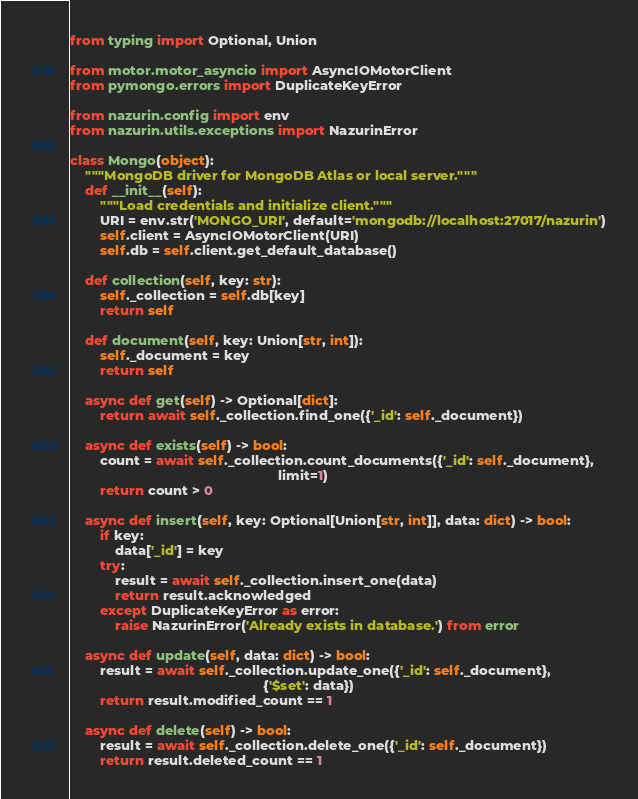Convert code to text. <code><loc_0><loc_0><loc_500><loc_500><_Python_>from typing import Optional, Union

from motor.motor_asyncio import AsyncIOMotorClient
from pymongo.errors import DuplicateKeyError

from nazurin.config import env
from nazurin.utils.exceptions import NazurinError

class Mongo(object):
    """MongoDB driver for MongoDB Atlas or local server."""
    def __init__(self):
        """Load credentials and initialize client."""
        URI = env.str('MONGO_URI', default='mongodb://localhost:27017/nazurin')
        self.client = AsyncIOMotorClient(URI)
        self.db = self.client.get_default_database()

    def collection(self, key: str):
        self._collection = self.db[key]
        return self

    def document(self, key: Union[str, int]):
        self._document = key
        return self

    async def get(self) -> Optional[dict]:
        return await self._collection.find_one({'_id': self._document})

    async def exists(self) -> bool:
        count = await self._collection.count_documents({'_id': self._document},
                                                       limit=1)
        return count > 0

    async def insert(self, key: Optional[Union[str, int]], data: dict) -> bool:
        if key:
            data['_id'] = key
        try:
            result = await self._collection.insert_one(data)
            return result.acknowledged
        except DuplicateKeyError as error:
            raise NazurinError('Already exists in database.') from error

    async def update(self, data: dict) -> bool:
        result = await self._collection.update_one({'_id': self._document},
                                                   {'$set': data})
        return result.modified_count == 1

    async def delete(self) -> bool:
        result = await self._collection.delete_one({'_id': self._document})
        return result.deleted_count == 1
</code> 